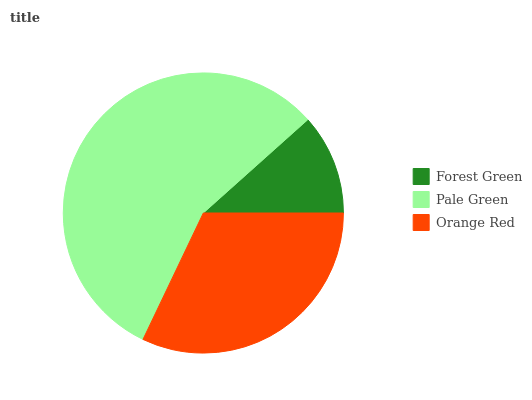Is Forest Green the minimum?
Answer yes or no. Yes. Is Pale Green the maximum?
Answer yes or no. Yes. Is Orange Red the minimum?
Answer yes or no. No. Is Orange Red the maximum?
Answer yes or no. No. Is Pale Green greater than Orange Red?
Answer yes or no. Yes. Is Orange Red less than Pale Green?
Answer yes or no. Yes. Is Orange Red greater than Pale Green?
Answer yes or no. No. Is Pale Green less than Orange Red?
Answer yes or no. No. Is Orange Red the high median?
Answer yes or no. Yes. Is Orange Red the low median?
Answer yes or no. Yes. Is Forest Green the high median?
Answer yes or no. No. Is Forest Green the low median?
Answer yes or no. No. 